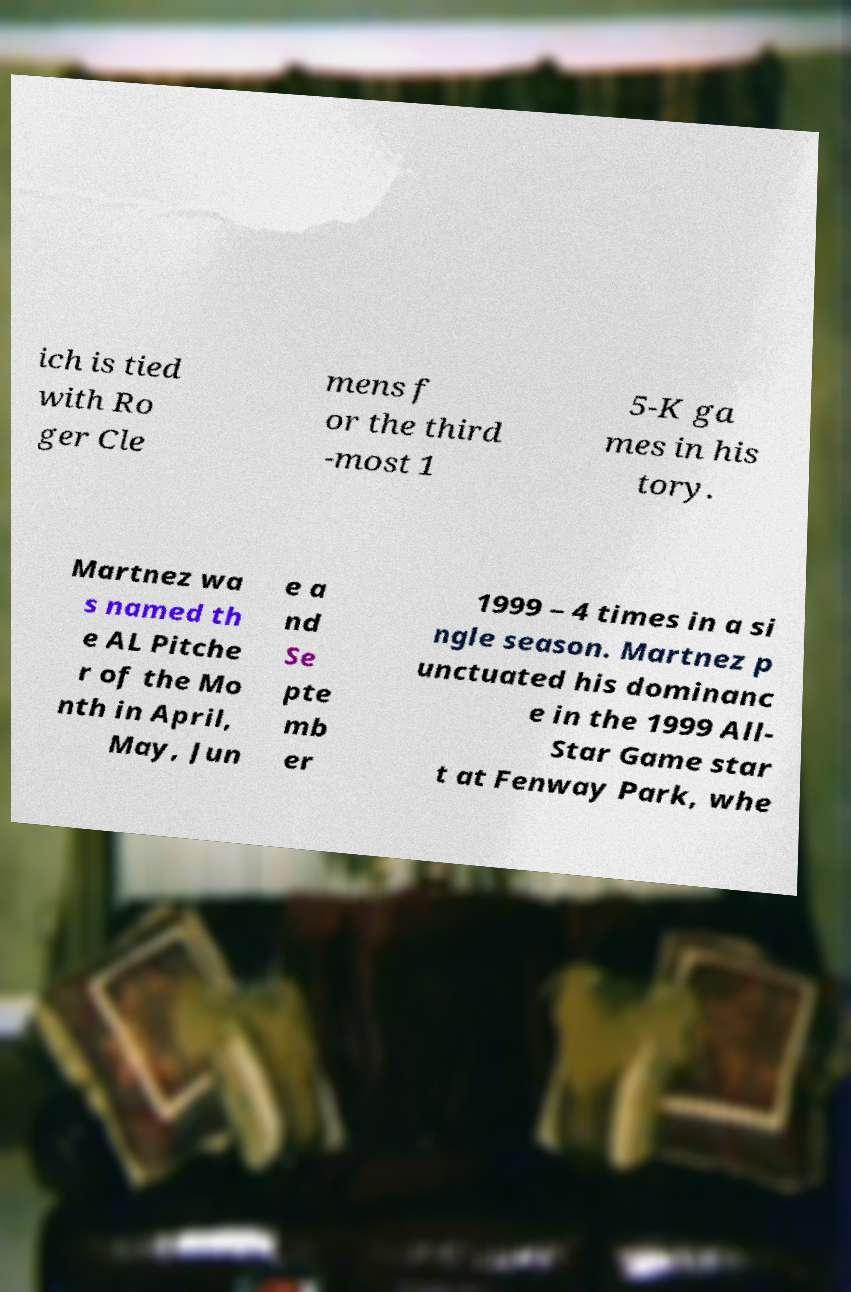I need the written content from this picture converted into text. Can you do that? ich is tied with Ro ger Cle mens f or the third -most 1 5-K ga mes in his tory. Martnez wa s named th e AL Pitche r of the Mo nth in April, May, Jun e a nd Se pte mb er 1999 – 4 times in a si ngle season. Martnez p unctuated his dominanc e in the 1999 All- Star Game star t at Fenway Park, whe 